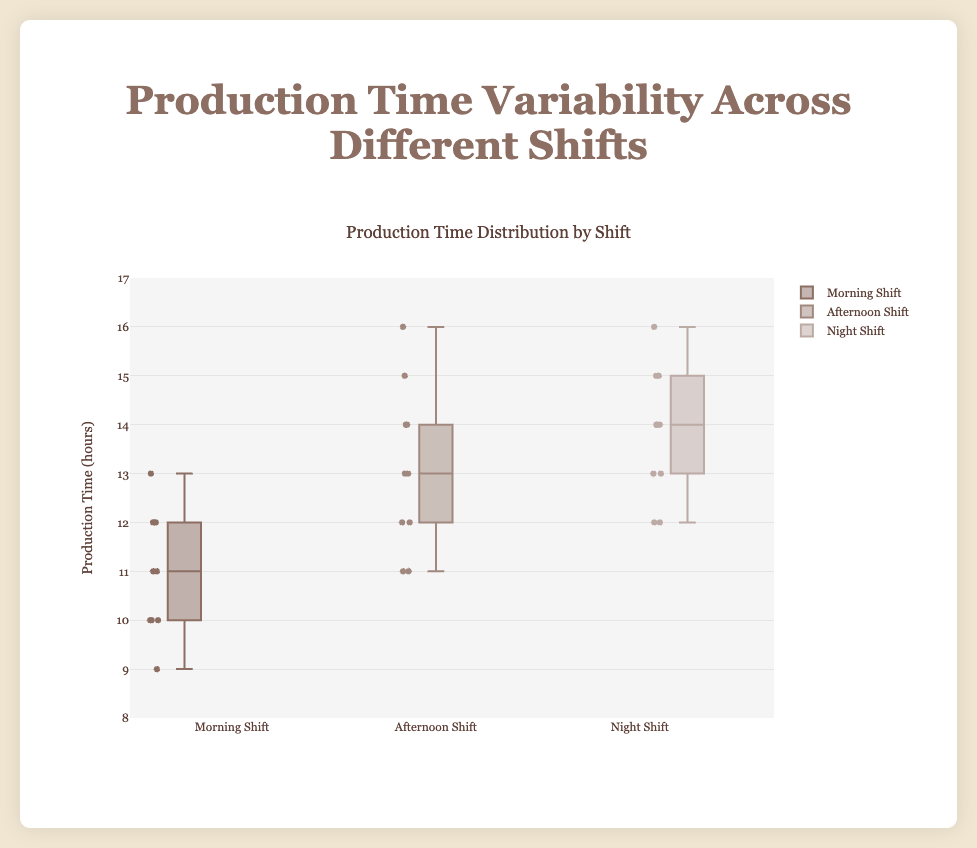Which shift has the highest median production time? The median value is indicated by the line inside the box. By looking at the lines, the Night Shift has the highest median value.
Answer: Night Shift What is the interquartile range (IQR) of the Morning Shift? The IQR is the difference between the first quartile (Q1) and the third quartile (Q3). For the Morning Shift, Q1 is 10 and Q3 is 12, so the IQR = 12 - 10 = 2.
Answer: 2 Which shift shows the greatest variability in production times? The variability can be measured by the length of the box and the whiskers. The Afternoon Shift has the longest box and whiskers, indicating the greatest variability.
Answer: Afternoon Shift Compare the median values of the Morning and Afternoon Shifts. Which one is greater? By comparing the median lines within the boxes, we see the Afternoon Shift's median is higher than that of the Morning Shift.
Answer: Afternoon Shift What is the range of production times for the Night Shift? The range is determined by the minimum and maximum values. For the Night Shift, the minimum is 12 and the maximum is 16, so the range = 16 - 12 = 4.
Answer: 4 How does the spread of data in the Morning Shift compare to the Afternoon Shift? The spread (variability) in the box plot can be seen by comparing the length of the boxes and whiskers. The Afternoon Shift has a wider spread than the Morning Shift.
Answer: Wider in Afternoon Shift Is there any overlap in the production times between the Morning Shift and the Night Shift? Checking the range of the production times, both shifts have data points in the range of 12-13. This indicates there is some overlap.
Answer: Yes What’s the difference between the highest production time in the Afternoon Shift and the highest production time in the Morning Shift? The highest production time for the Afternoon Shift is 16, and for the Morning Shift, it is 13. The difference is 16 - 13 = 3.
Answer: 3 Compare the production time distributions between the Night Shift and the Afternoon Shift in terms of symmetry and outliers. Both shifts don't show significant outliers and are relatively symmetric, but the Afternoon Shift has a slightly more spread out and potentially asymmetric distribution compared to the Night Shift.
Answer: Afternoon Shift more spread out Which shift has the lowest minimum production time? The minimum production time can be identified by the lower whisker of the box plot. The Morning Shift has the lowest minimum production time of 9 hours.
Answer: Morning Shift 